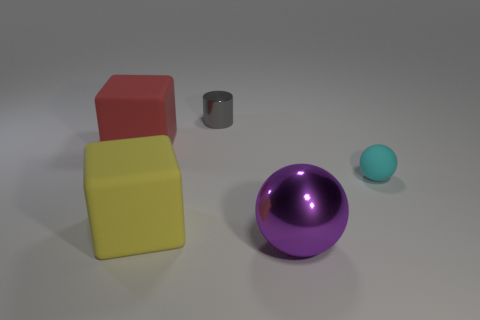How many things are behind the small cyan rubber ball and in front of the yellow matte thing?
Keep it short and to the point. 0. Is the number of tiny gray shiny objects that are to the right of the tiny cylinder less than the number of metallic balls that are behind the yellow rubber object?
Your answer should be compact. No. Do the large yellow matte thing and the red thing have the same shape?
Make the answer very short. Yes. How many other objects are the same size as the matte sphere?
Your response must be concise. 1. What number of objects are either objects on the left side of the large metallic object or big cubes on the right side of the red matte cube?
Ensure brevity in your answer.  3. What number of other tiny cyan rubber things have the same shape as the small cyan matte thing?
Keep it short and to the point. 0. What is the material of the object that is left of the cylinder and behind the rubber sphere?
Ensure brevity in your answer.  Rubber. What number of big red matte objects are right of the tiny gray shiny object?
Your answer should be very brief. 0. How many tiny gray metal cylinders are there?
Provide a succinct answer. 1. Is the size of the cyan rubber sphere the same as the yellow matte object?
Your answer should be compact. No. 